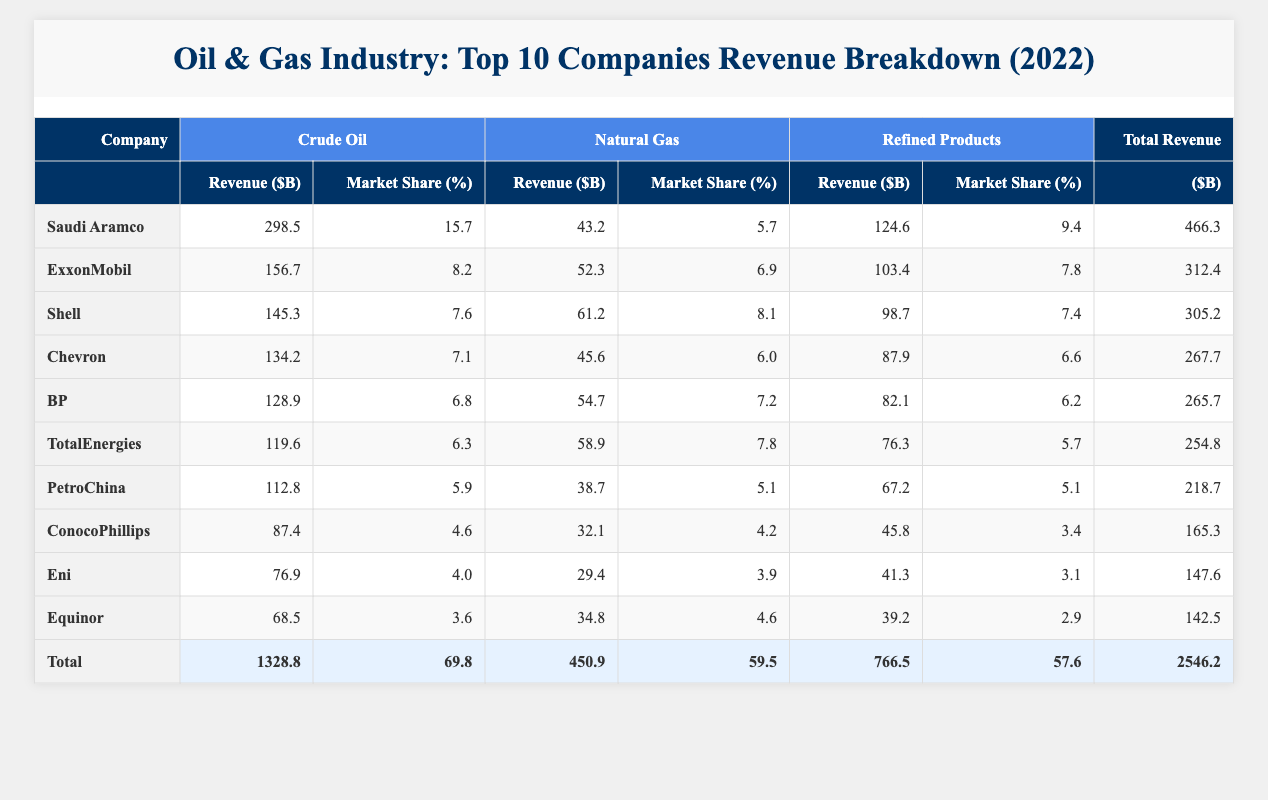What is the total revenue for Saudi Aramco? The revenue for Saudi Aramco is located in the "Total Revenue" column for that company, which is listed as 466.3 billion dollars.
Answer: 466.3 Which company has the highest revenue from Natural Gas? By comparing the revenue figures for Natural Gas, Saudi Aramco has 43.2 billion dollars, while ExxonMobil and Shell have 52.3 and 61.2 billion dollars respectively. Thus, Shell has the highest revenue for Natural Gas.
Answer: Shell What is the average market share of all companies for Refined Products? The market shares for Refined Products from the table are: 9.4, 7.8, 7.4, 6.6, 6.2, 5.7, 5.1, 3.4, 3.1, and 2.9. Their sum is 55.6, and there are 10 companies, so the average is 55.6 divided by 10, resulting in 5.56.
Answer: 5.56 Is the market share of Eni higher than that of ConocoPhillips for Crude Oil? Eni's market share for Crude Oil is 4.0, while ConocoPhillips' is 4.6. Hence, Eni does not have a higher market share; it is lower.
Answer: No What is the combined revenue generated from all companies concerning Natural Gas? The revenues for Natural Gas are: 43.2 (Saudi Aramco) + 52.3 (ExxonMobil) + 61.2 (Shell) + 45.6 (Chevron) + 54.7 (BP) + 58.9 (TotalEnergies) + 38.7 (PetroChina) + 32.1 (ConocoPhillips) + 29.4 (Eni) + 34.8 (Equinor), which sums up to 450.9 billion dollars.
Answer: 450.9 Which company has the lowest market share for Natural Gas? By examining the market shares listed for Natural Gas, PetroChina has the lowest percentage at 5.1%.
Answer: PetroChina 